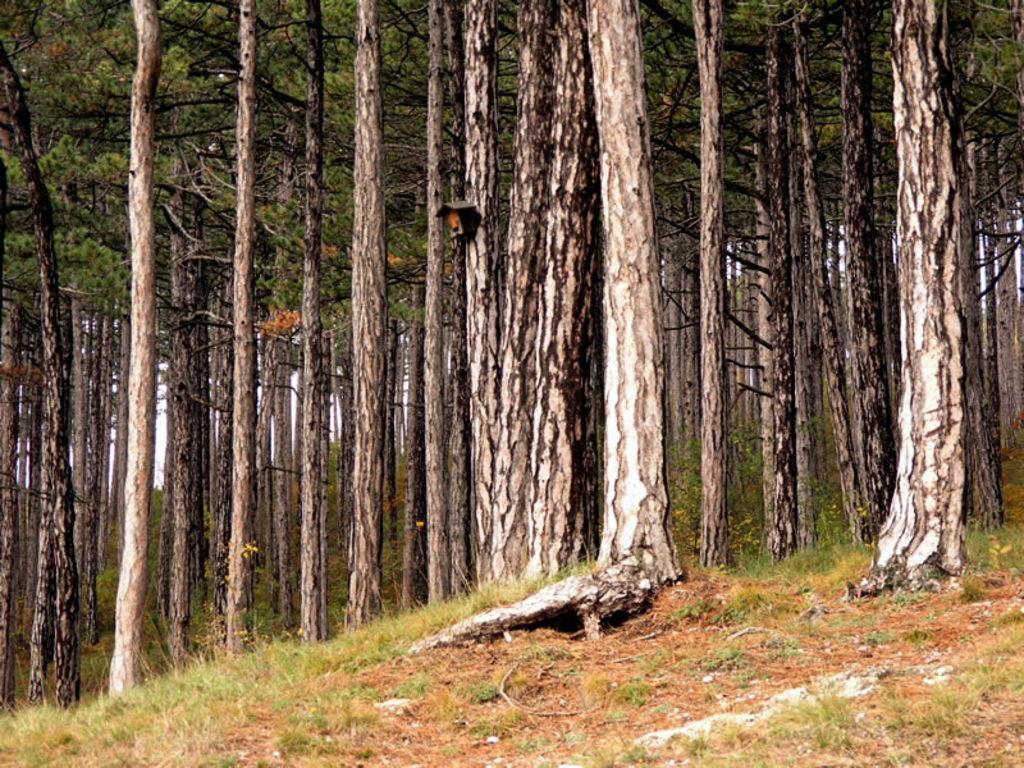Can you describe this image briefly? Here we can see grass and number of trees. 